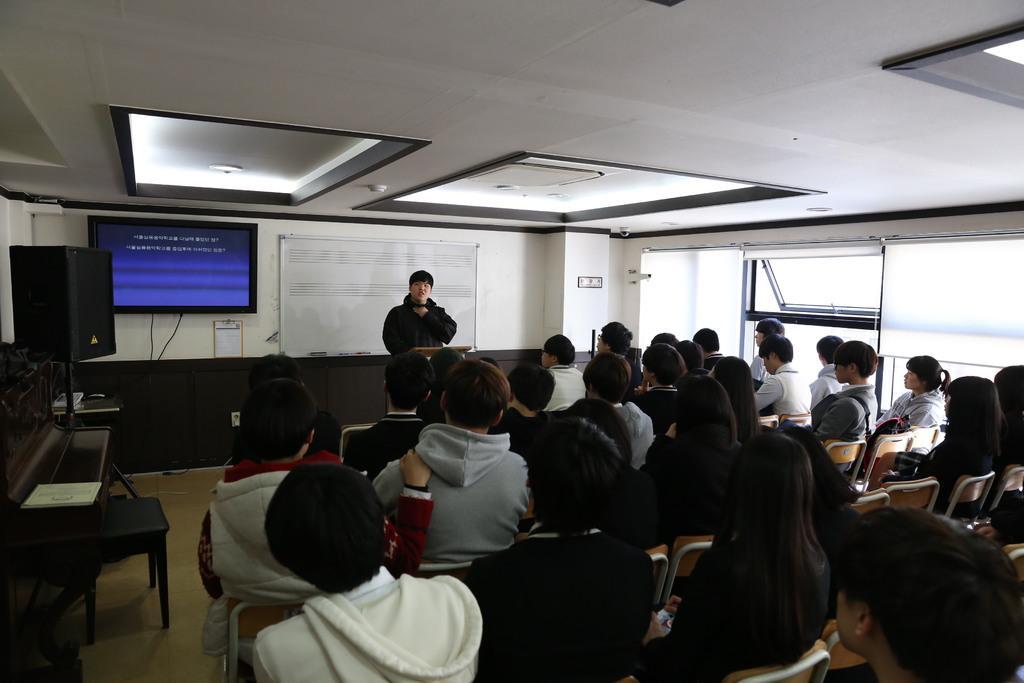In one or two sentences, can you explain what this image depicts? There are many people sitting on the chairs. On the right side there is a window. In the back there's a wall with screen and a board. On the left side there is a piano and a stool. Near to that there is a speaker on a stand. In the back there is a stand and a person is standing. 